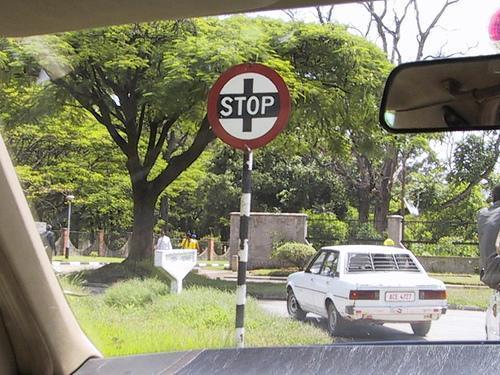How many stop signs are there?
Give a very brief answer. 1. How many white cars are there?
Give a very brief answer. 1. How many licence plates are in the picture?
Give a very brief answer. 1. 